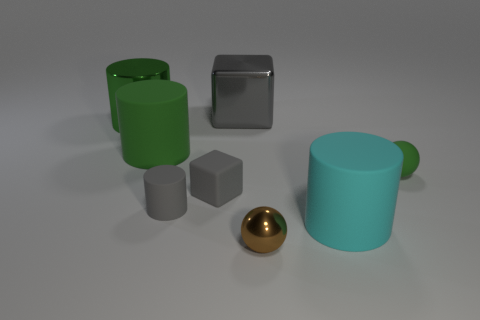Add 1 tiny yellow matte objects. How many objects exist? 9 Subtract all red cylinders. Subtract all brown cubes. How many cylinders are left? 4 Subtract all spheres. How many objects are left? 6 Subtract all big cyan matte cylinders. Subtract all rubber blocks. How many objects are left? 6 Add 8 large green metallic objects. How many large green metallic objects are left? 9 Add 3 tiny cyan matte cubes. How many tiny cyan matte cubes exist? 3 Subtract 0 yellow balls. How many objects are left? 8 